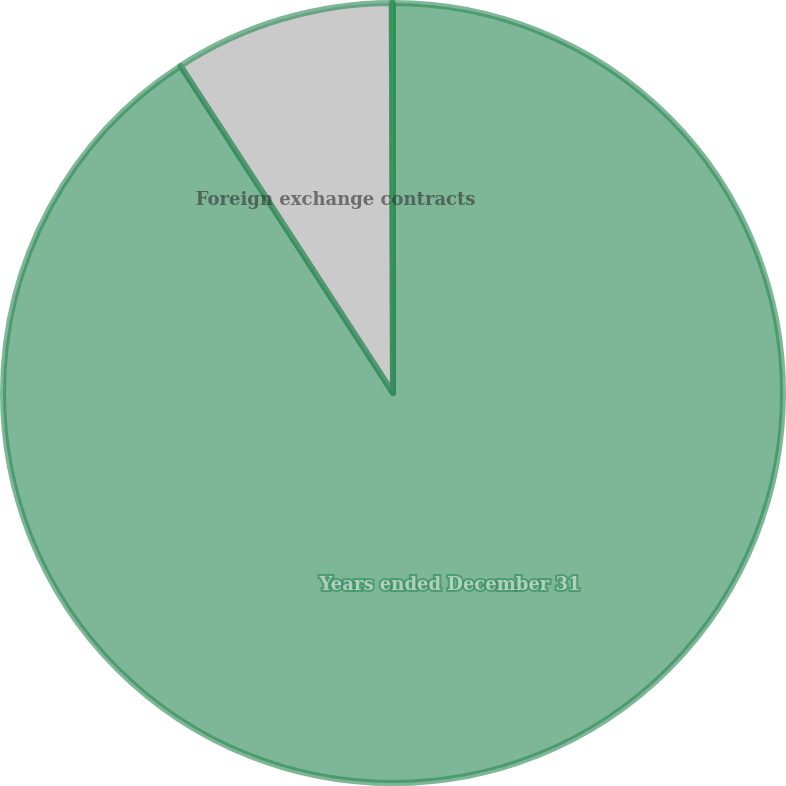Convert chart to OTSL. <chart><loc_0><loc_0><loc_500><loc_500><pie_chart><fcel>Years ended December 31<fcel>Foreign exchange contracts<fcel>Commodity contracts<nl><fcel>90.83%<fcel>9.12%<fcel>0.05%<nl></chart> 